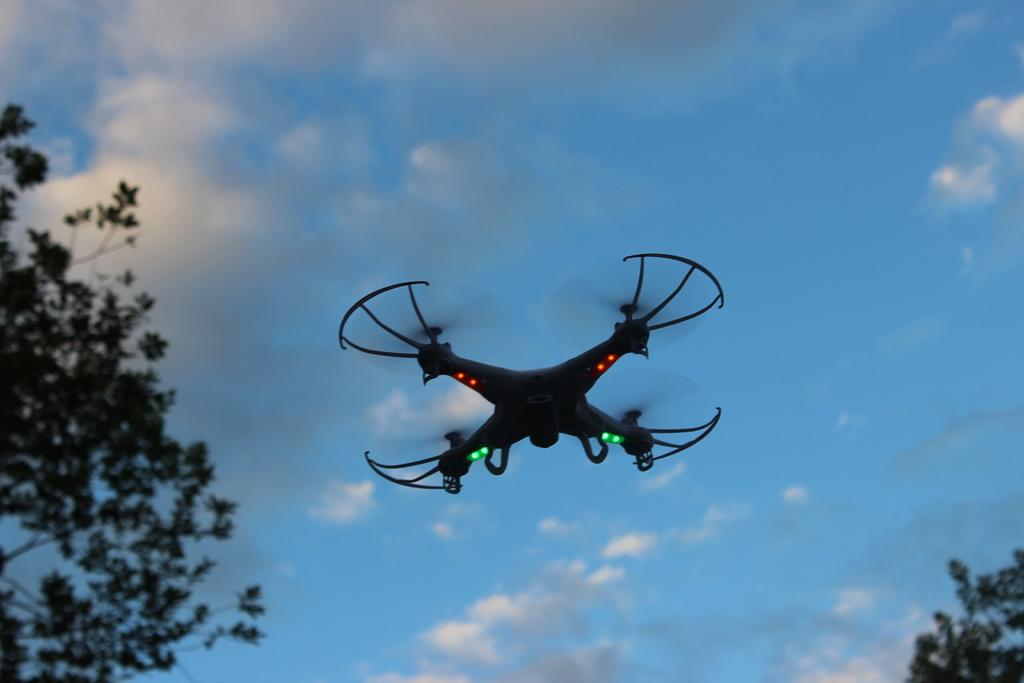What is the main subject of the image? The main subject of the image is a drone camera. What can be seen in the background of the image? The background of the image is covered with trees, and the sky is also visible. Can you tell if the image was taken during the day or night? The image was likely taken during the day, as there is no indication of darkness or artificial lighting. What type of bean is being used to care for the trees in the image? There is no bean or indication of tree care in the image; it features a drone camera with a background of trees and the sky. 